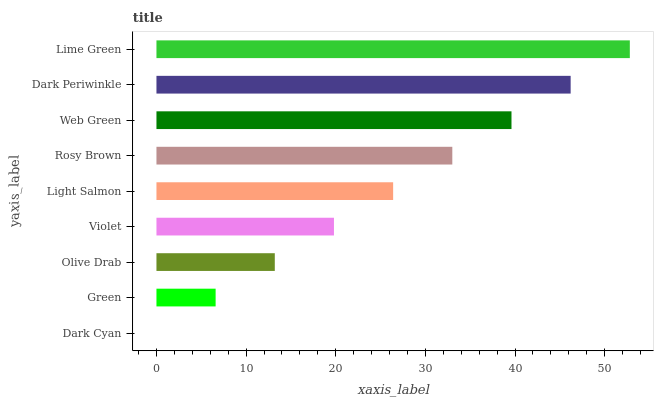Is Dark Cyan the minimum?
Answer yes or no. Yes. Is Lime Green the maximum?
Answer yes or no. Yes. Is Green the minimum?
Answer yes or no. No. Is Green the maximum?
Answer yes or no. No. Is Green greater than Dark Cyan?
Answer yes or no. Yes. Is Dark Cyan less than Green?
Answer yes or no. Yes. Is Dark Cyan greater than Green?
Answer yes or no. No. Is Green less than Dark Cyan?
Answer yes or no. No. Is Light Salmon the high median?
Answer yes or no. Yes. Is Light Salmon the low median?
Answer yes or no. Yes. Is Lime Green the high median?
Answer yes or no. No. Is Lime Green the low median?
Answer yes or no. No. 